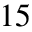<formula> <loc_0><loc_0><loc_500><loc_500>1 5</formula> 